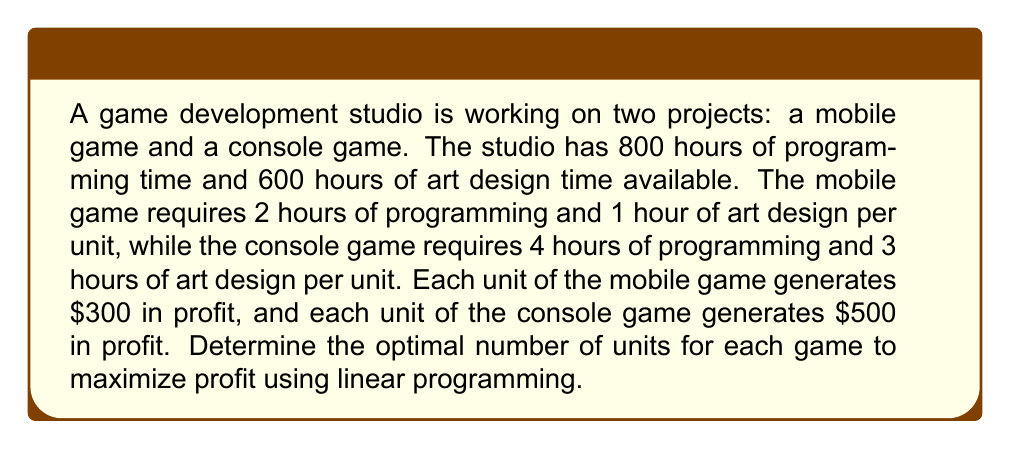Give your solution to this math problem. Let's solve this problem step-by-step using linear programming:

1. Define variables:
   Let $x$ = number of mobile game units
   Let $y$ = number of console game units

2. Formulate the objective function:
   Maximize profit: $Z = 300x + 500y$

3. Identify constraints:
   Programming time: $2x + 4y \leq 800$
   Art design time: $x + 3y \leq 600$
   Non-negativity: $x \geq 0, y \geq 0$

4. Graph the constraints:
   [asy]
   import graph;
   size(200,200);
   xaxis("x",0,400,Arrow);
   yaxis("y",0,250,Arrow);
   draw((0,200)--(400,0),blue);
   draw((0,200)--(600,0),red);
   label("2x + 4y = 800",(200,100),E,blue);
   label("x + 3y = 600",(300,100),W,red);
   fill((0,0)--(0,200)--(300,100)--(400,0)--cycle,lightgray);
   [/asy]

5. Identify corner points:
   (0,0), (0,200), (300,100), (400,0)

6. Evaluate the objective function at each corner point:
   Z(0,0) = 0
   Z(0,200) = 100,000
   Z(300,100) = 140,000
   Z(400,0) = 120,000

7. The maximum profit occurs at the point (300,100)

Therefore, the optimal solution is to produce 300 units of the mobile game and 100 units of the console game, resulting in a maximum profit of $140,000.
Answer: Mobile game: 300 units; Console game: 100 units 